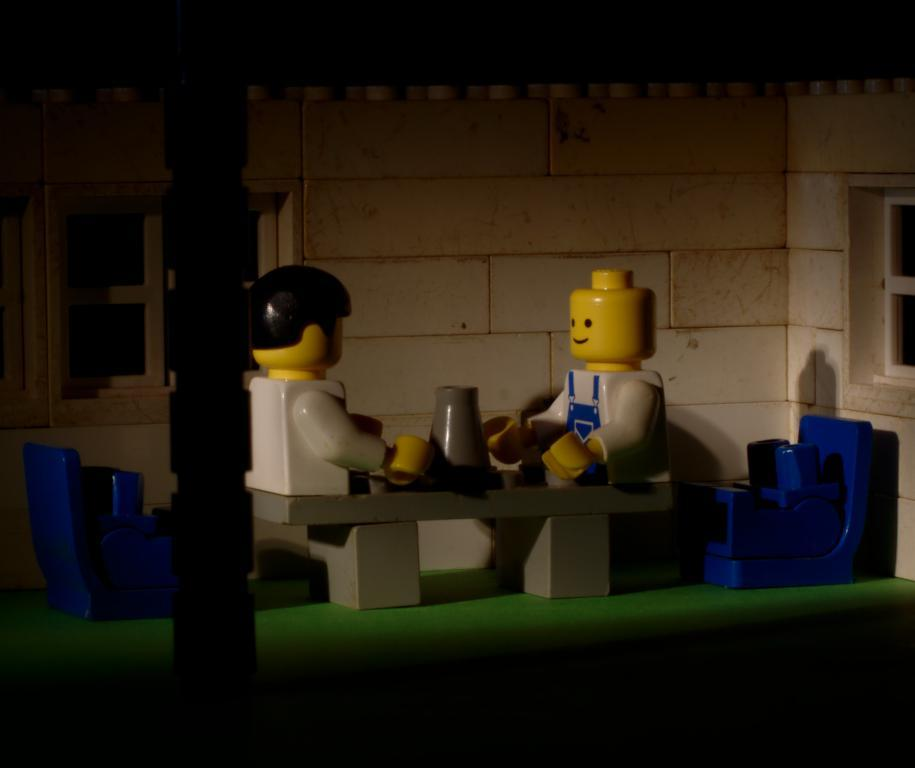What objects are on the table in the image? There are toys on the table in the image. What type of furniture is present for the toys? There are toy chairs in the image. What can be seen on the wall in the image? There is a wall visible in the image. What architectural feature allows natural light into the room? There are windows in the image. What type of pie is being served to the friend in the image? There is no friend or pie present in the image. 